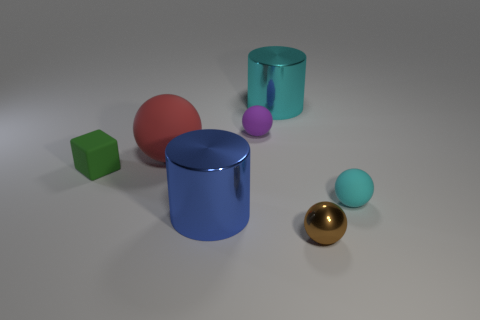Subtract all cyan balls. How many balls are left? 3 Subtract all purple spheres. How many spheres are left? 3 Add 2 green rubber things. How many objects exist? 9 Subtract all spheres. How many objects are left? 3 Subtract all blue spheres. Subtract all yellow cubes. How many spheres are left? 4 Add 2 tiny shiny spheres. How many tiny shiny spheres exist? 3 Subtract 0 blue cubes. How many objects are left? 7 Subtract all rubber things. Subtract all small purple rubber things. How many objects are left? 2 Add 4 big cyan things. How many big cyan things are left? 5 